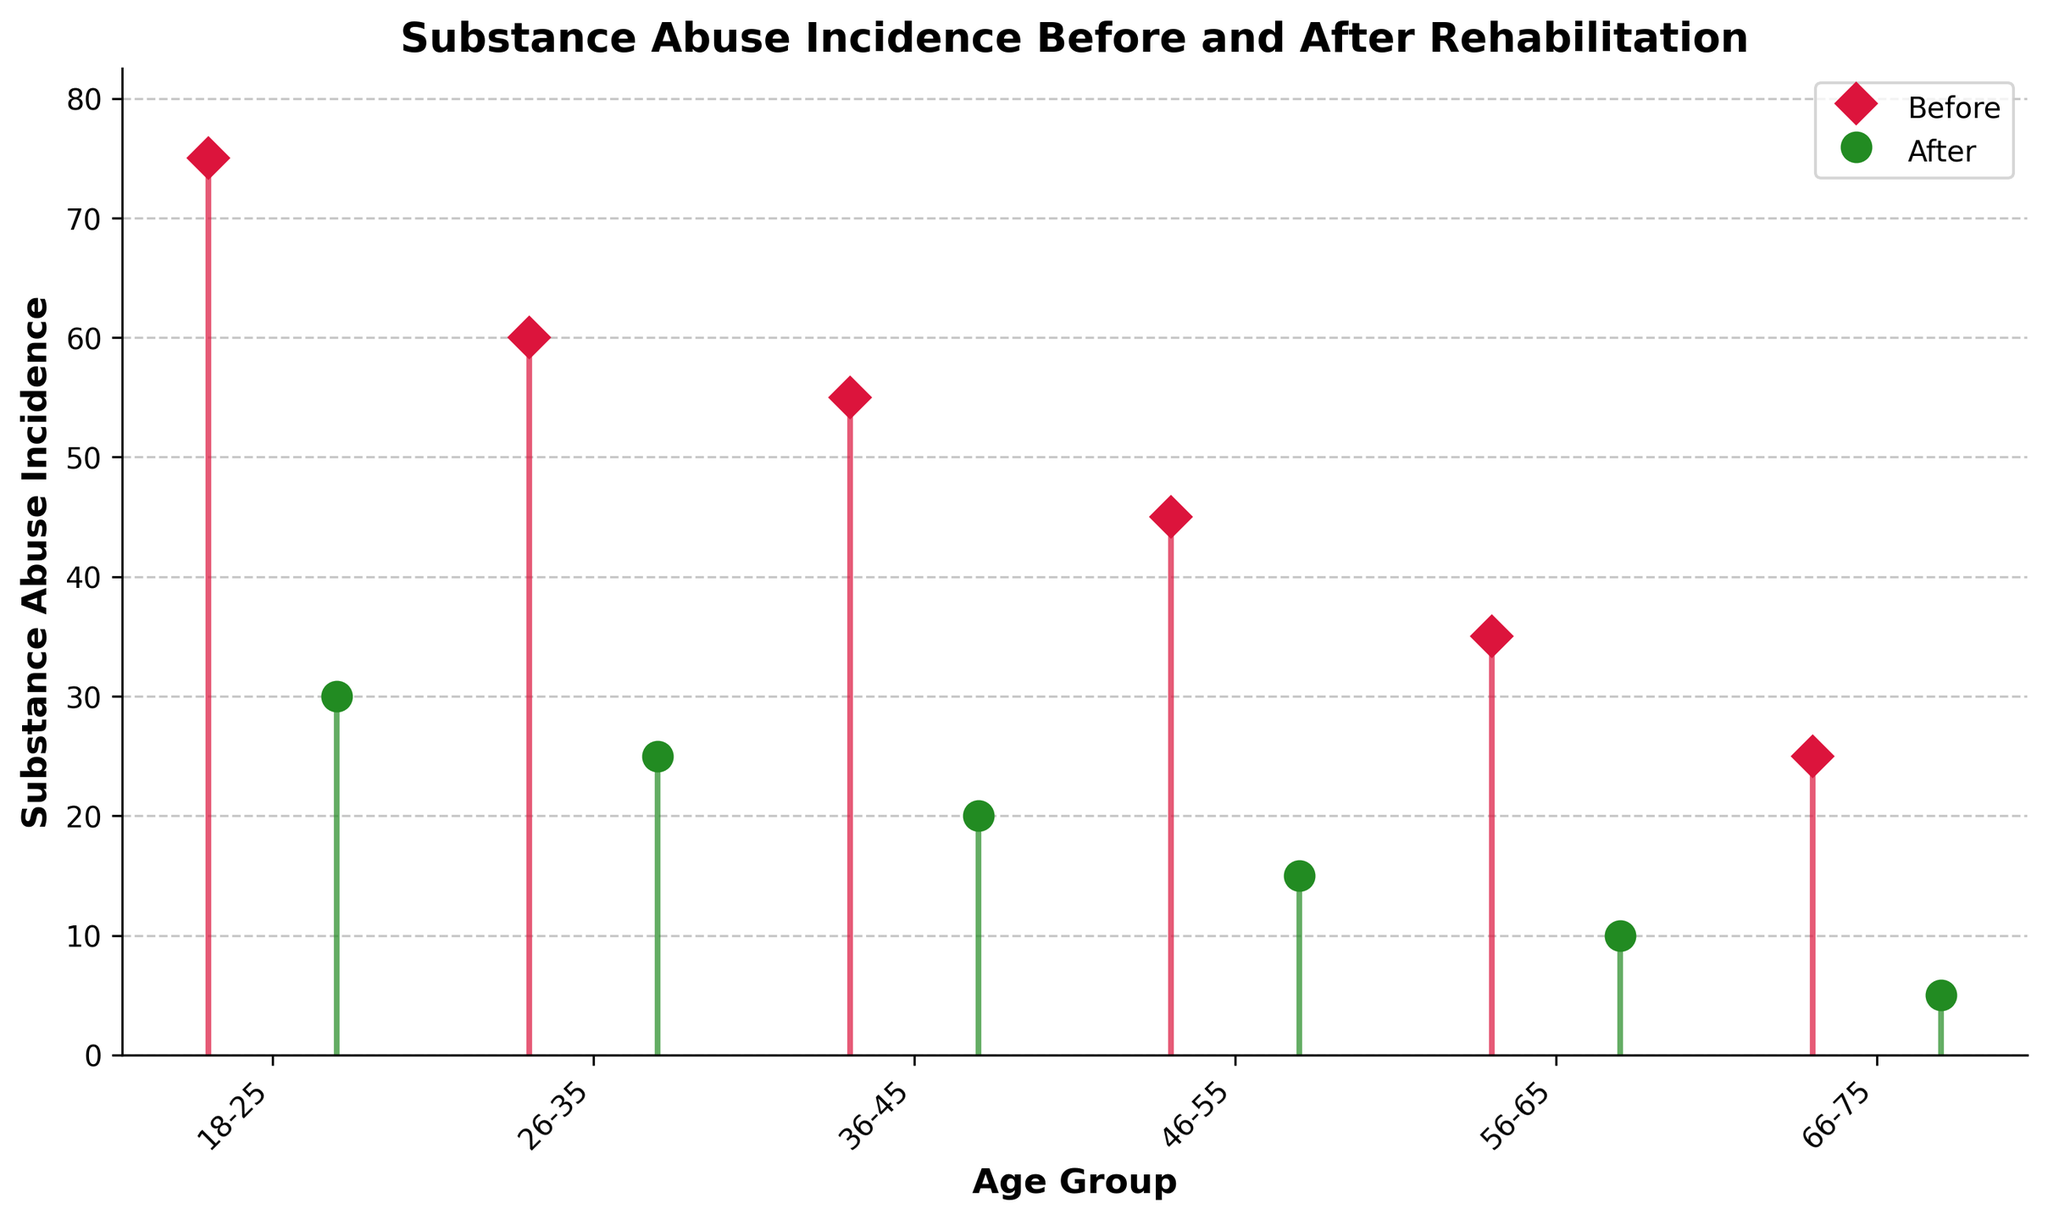What is the title of the plot? The title is located at the top of the plot, and it is meant to describe what the plot represents. In this case, it states the focus of the study.
Answer: Substance Abuse Incidence Before and After Rehabilitation What age group has the highest substance abuse incidence before rehabilitation? The higher part of the 'Before' stem lines indicator represents substance abuse before rehabilitation for each age group. The tallest 'Before' stem line indicates the highest incidence. This belongs to the 18-25 age group.
Answer: 18-25 How does the substance abuse incidence change in the 36-45 age group after rehabilitation? To understand the change, compare the height of the 'Before' and 'After' stem lines for the 36-45 age group. The 'Before' stem line starts at 55 and the 'After' stem line ends at 20. Subtracting these gives the difference.
Answer: 35 Which age group has the smallest reduction in substance abuse incidence after rehabilitation? To identify this, calculate the difference between 'Before' and 'After' for each age group, then determine which age group has the smallest difference. The 66-75 age group has a reduction from 25 to 5, which is the smallest reduction of 20.
Answer: 66-75 What is the overall trend visible in the plot for substance abuse incidence before and after rehabilitation? Observing the general direction of the stem lines before and after rehabilitation across all age groups, there is a noticeable trend of decline in the 'After' category compared to the 'Before' category, indicating effectiveness.
Answer: Decreasing trend after rehabilitation What would be the average substance abuse incidence before and after rehabilitation for the 26-35 age group? Look at both stem lines for 'Before' and 'After' in the 26-35 age group. The 'Before' value is 60 and 'After' value is 25. Average these two values: (60 + 25) / 2.
Answer: 42.5 Which color represents the substance abuse incidence after rehabilitation? Observing the plot, identify the color of the markers used for 'After' rehabilitation. The specified color for this category in the plot is green.
Answer: Green Between which two age groups is the largest decrease in substance abuse incidence observed after rehabilitation? Calculate the difference between 'Before' and 'After' for each age group. The largest difference appears in the 18-25 age group, where the drop is from 75 to 30, which is a difference of 45.
Answer: 18-25 What is the range of substance abuse incidence before rehabilitation among all age groups? The range is calculated by subtracting the smallest 'Before' value from the largest 'Before' value. The highest 'Before' value is 75 (for 18-25), and the lowest is 25 (for 66-75). Therefore, the range is 75-25.
Answer: 50 